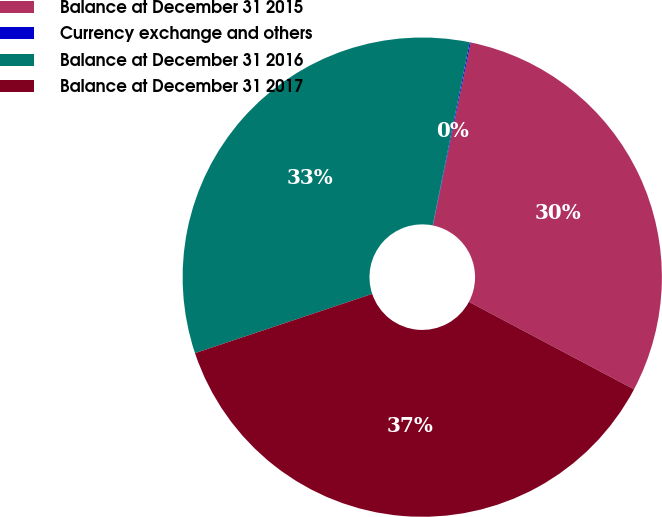<chart> <loc_0><loc_0><loc_500><loc_500><pie_chart><fcel>Balance at December 31 2015<fcel>Currency exchange and others<fcel>Balance at December 31 2016<fcel>Balance at December 31 2017<nl><fcel>29.51%<fcel>0.07%<fcel>33.31%<fcel>37.11%<nl></chart> 